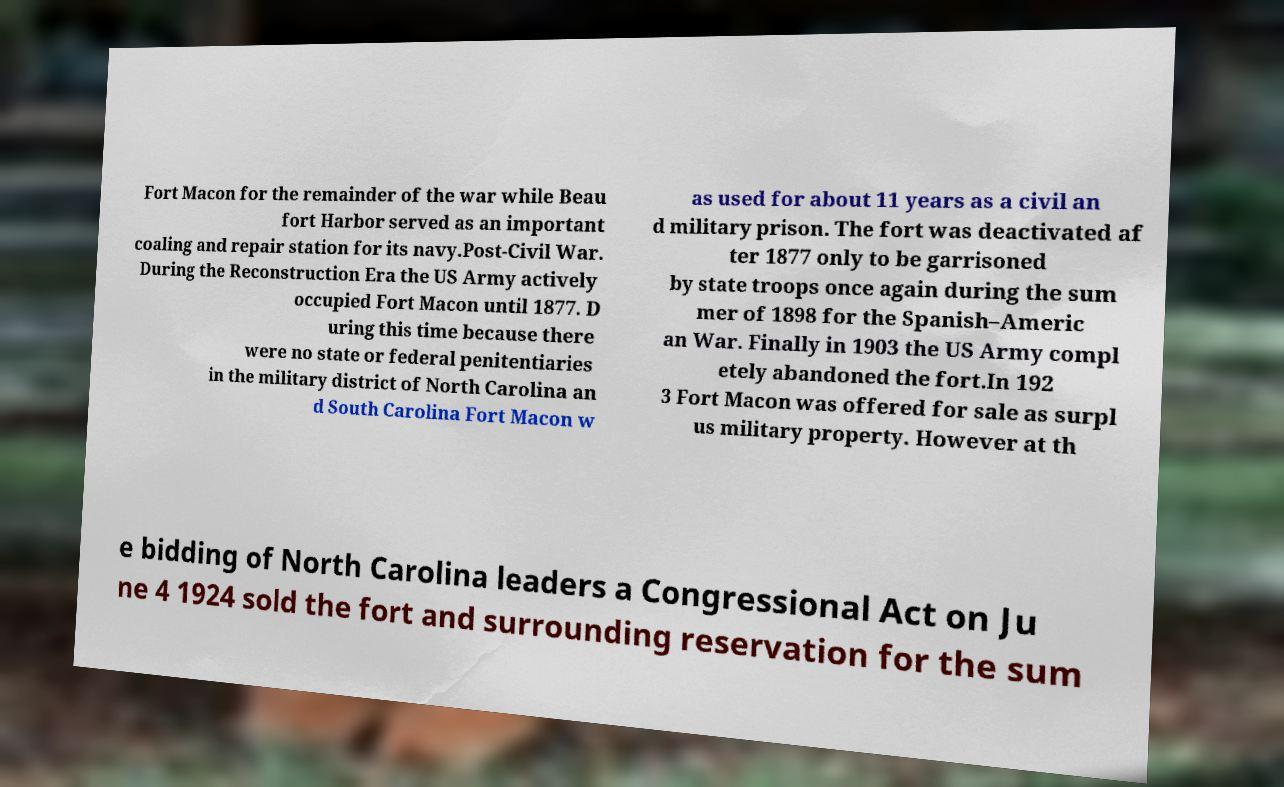Can you read and provide the text displayed in the image?This photo seems to have some interesting text. Can you extract and type it out for me? Fort Macon for the remainder of the war while Beau fort Harbor served as an important coaling and repair station for its navy.Post-Civil War. During the Reconstruction Era the US Army actively occupied Fort Macon until 1877. D uring this time because there were no state or federal penitentiaries in the military district of North Carolina an d South Carolina Fort Macon w as used for about 11 years as a civil an d military prison. The fort was deactivated af ter 1877 only to be garrisoned by state troops once again during the sum mer of 1898 for the Spanish–Americ an War. Finally in 1903 the US Army compl etely abandoned the fort.In 192 3 Fort Macon was offered for sale as surpl us military property. However at th e bidding of North Carolina leaders a Congressional Act on Ju ne 4 1924 sold the fort and surrounding reservation for the sum 